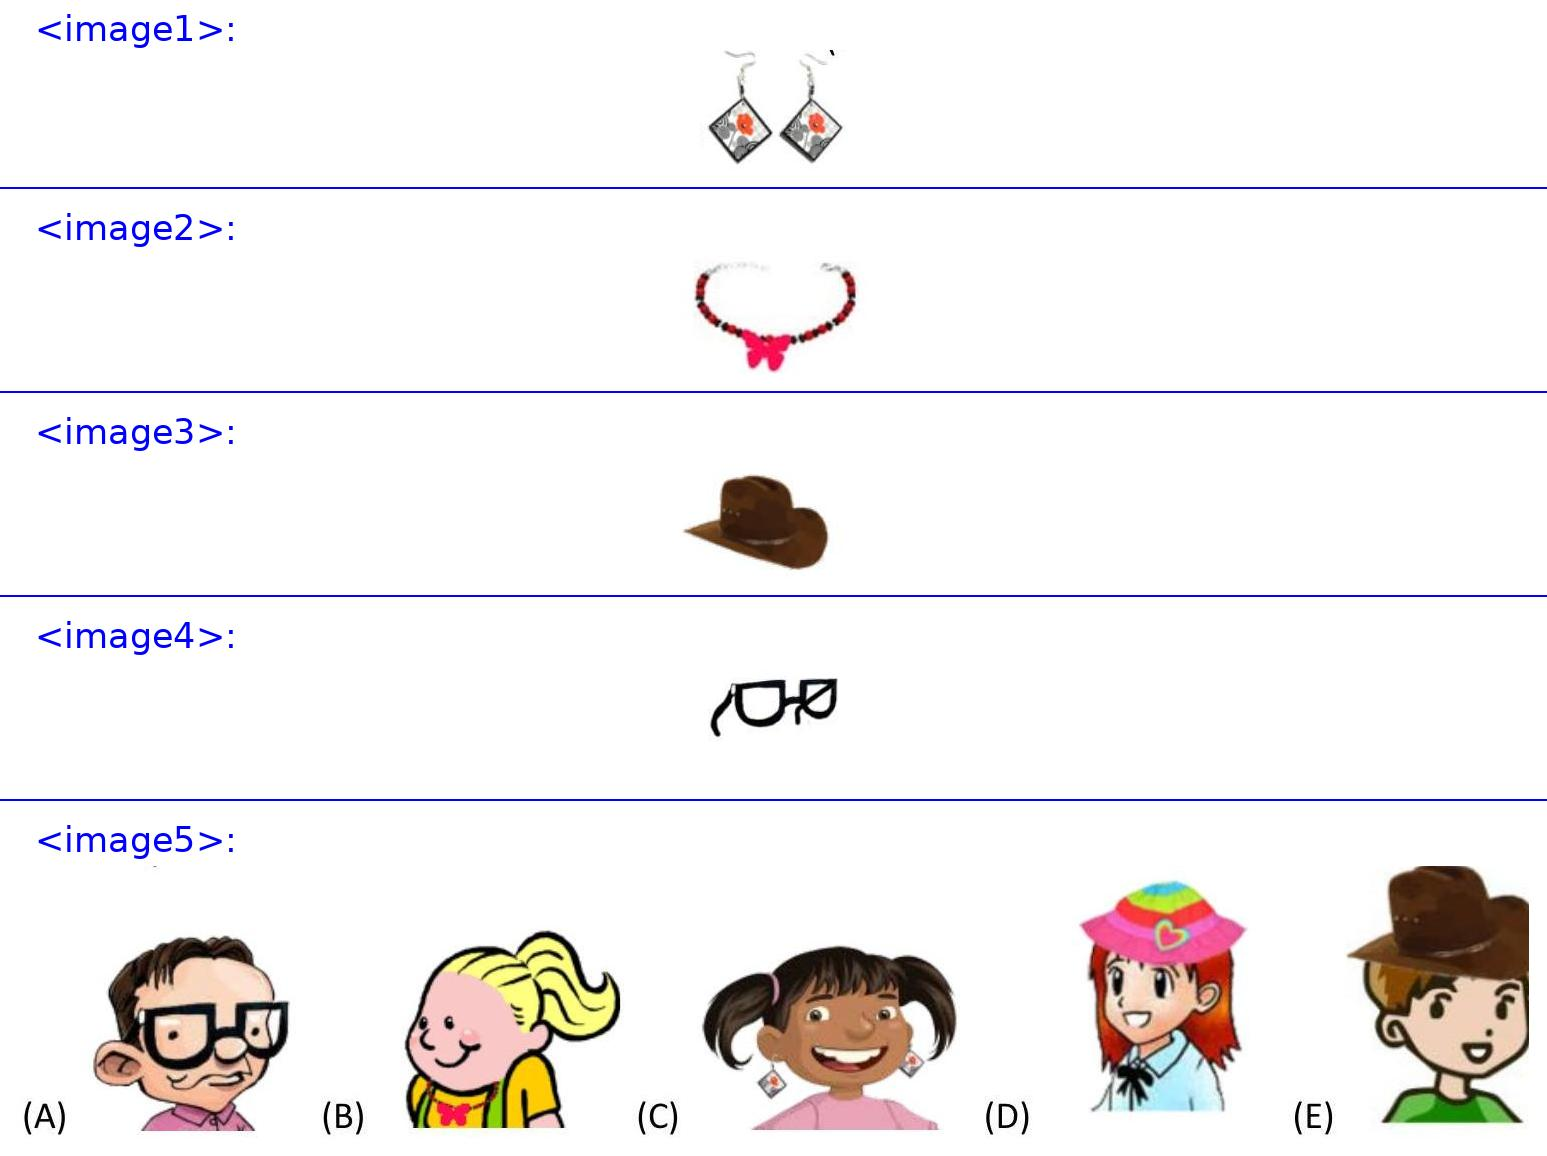<image1> What type of style do these earrings represent? Those earrings have a very modern and chic design, featuring diamond shapes and a vivid floral print which suggests a contemporary style with a touch of traditional charm. 